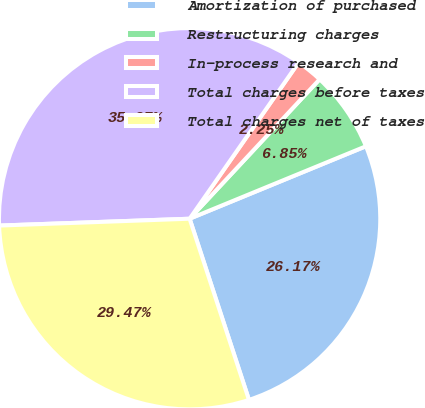Convert chart. <chart><loc_0><loc_0><loc_500><loc_500><pie_chart><fcel>Amortization of purchased<fcel>Restructuring charges<fcel>In-process research and<fcel>Total charges before taxes<fcel>Total charges net of taxes<nl><fcel>26.17%<fcel>6.85%<fcel>2.25%<fcel>35.27%<fcel>29.47%<nl></chart> 